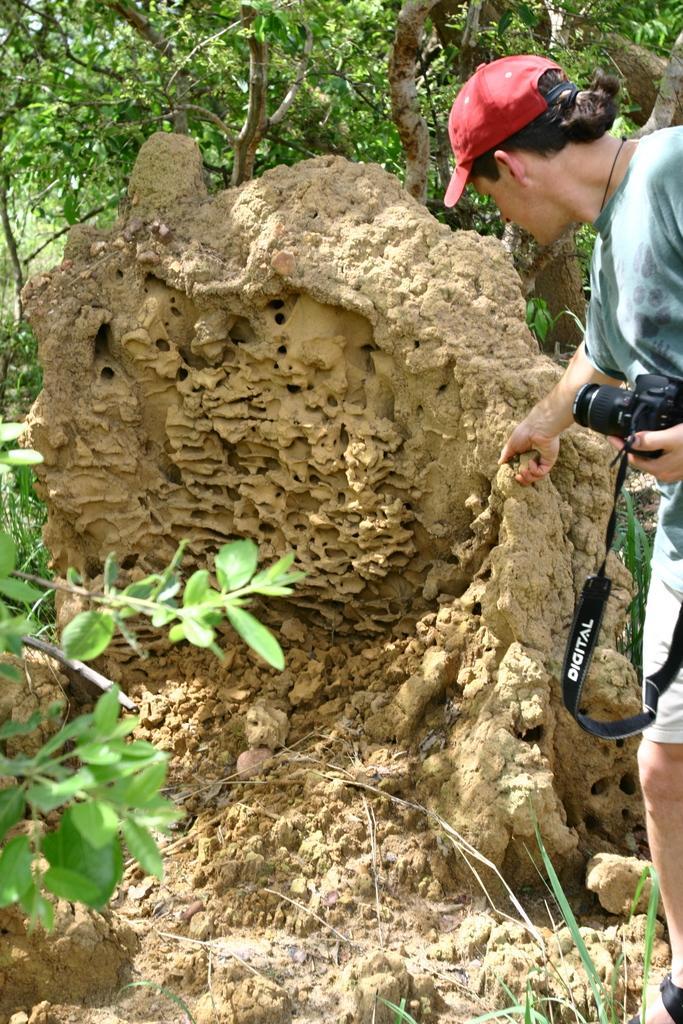In one or two sentences, can you explain what this image depicts? In this picture we can see a person is standing and holding a camera, on the left side there is a plant, in the background we can see trees. 